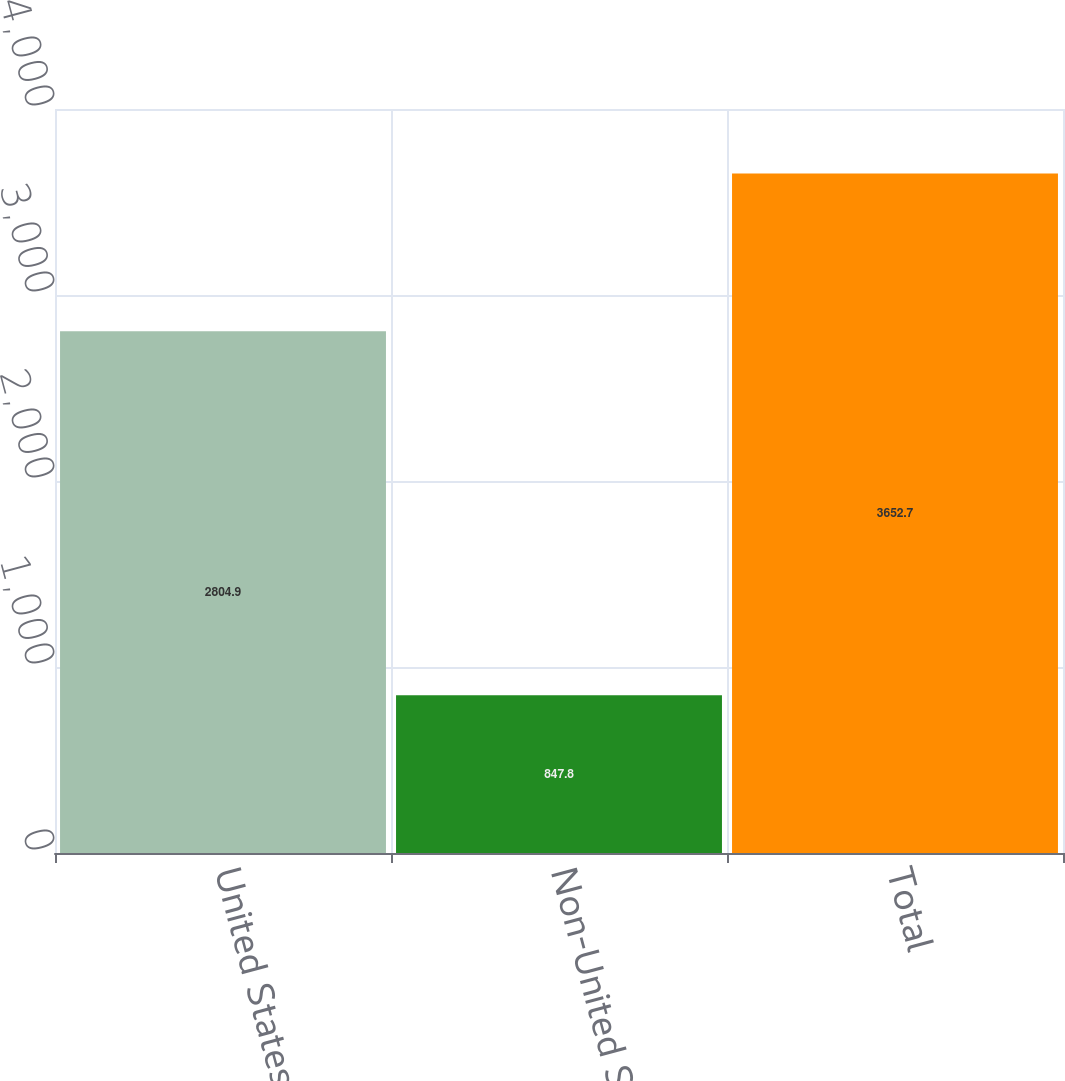Convert chart to OTSL. <chart><loc_0><loc_0><loc_500><loc_500><bar_chart><fcel>United States<fcel>Non-United States<fcel>Total<nl><fcel>2804.9<fcel>847.8<fcel>3652.7<nl></chart> 